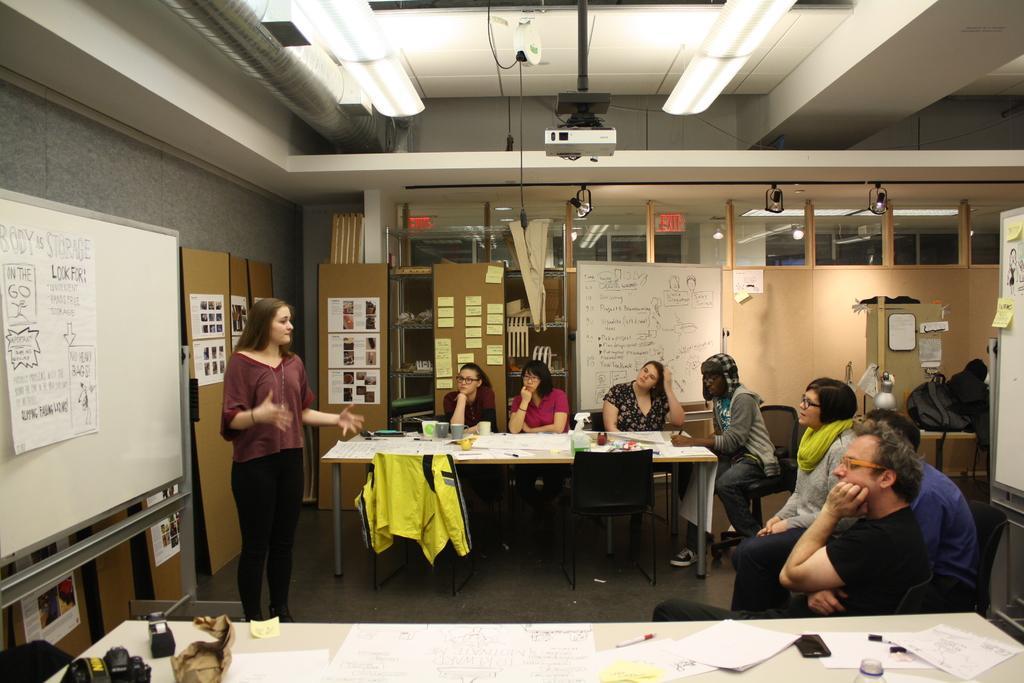Can you describe this image briefly? In this picture we can see a group of people sitting on chairs and in middle woman is standing and talking and beside to her we can see board with poster, sticker, wall, lamp, projector, light and here on table we can see bottle, papers, mobile, pen, camera. 